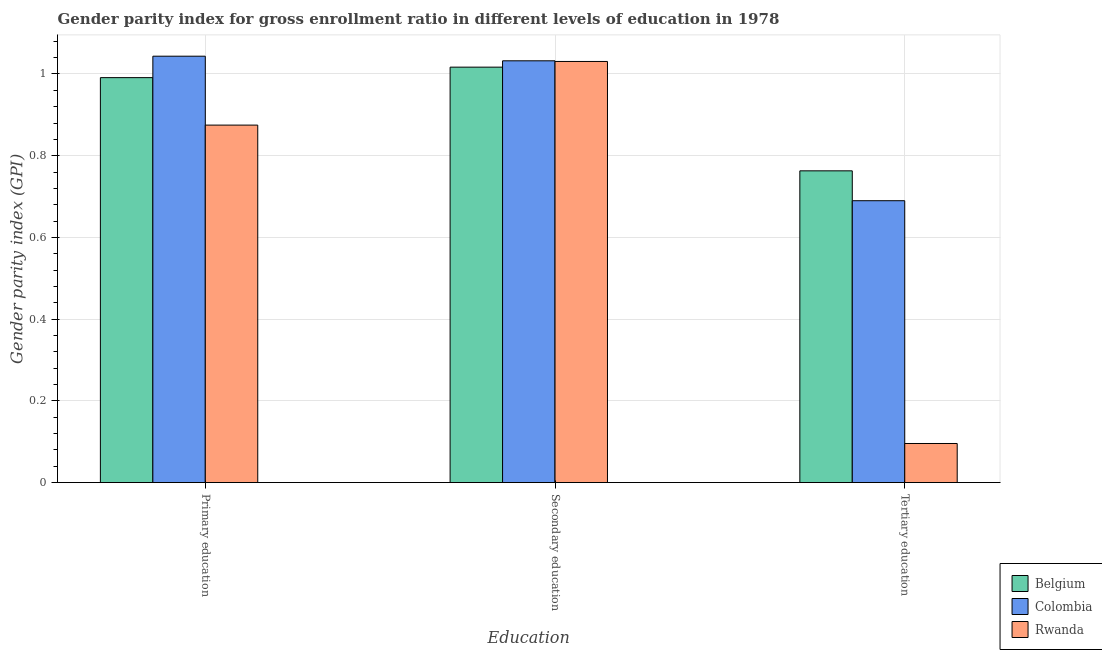How many different coloured bars are there?
Make the answer very short. 3. Are the number of bars per tick equal to the number of legend labels?
Your answer should be compact. Yes. What is the label of the 2nd group of bars from the left?
Ensure brevity in your answer.  Secondary education. What is the gender parity index in tertiary education in Belgium?
Keep it short and to the point. 0.76. Across all countries, what is the maximum gender parity index in tertiary education?
Keep it short and to the point. 0.76. Across all countries, what is the minimum gender parity index in primary education?
Ensure brevity in your answer.  0.87. In which country was the gender parity index in secondary education maximum?
Offer a terse response. Colombia. In which country was the gender parity index in primary education minimum?
Your answer should be very brief. Rwanda. What is the total gender parity index in tertiary education in the graph?
Your answer should be very brief. 1.55. What is the difference between the gender parity index in tertiary education in Belgium and that in Rwanda?
Your answer should be very brief. 0.67. What is the difference between the gender parity index in tertiary education in Belgium and the gender parity index in primary education in Rwanda?
Keep it short and to the point. -0.11. What is the average gender parity index in secondary education per country?
Offer a very short reply. 1.03. What is the difference between the gender parity index in secondary education and gender parity index in tertiary education in Rwanda?
Keep it short and to the point. 0.93. In how many countries, is the gender parity index in secondary education greater than 0.16 ?
Your answer should be compact. 3. What is the ratio of the gender parity index in primary education in Rwanda to that in Colombia?
Offer a terse response. 0.84. Is the difference between the gender parity index in secondary education in Belgium and Rwanda greater than the difference between the gender parity index in primary education in Belgium and Rwanda?
Your answer should be compact. No. What is the difference between the highest and the second highest gender parity index in tertiary education?
Ensure brevity in your answer.  0.07. What is the difference between the highest and the lowest gender parity index in secondary education?
Provide a short and direct response. 0.02. What does the 2nd bar from the left in Secondary education represents?
Your response must be concise. Colombia. Is it the case that in every country, the sum of the gender parity index in primary education and gender parity index in secondary education is greater than the gender parity index in tertiary education?
Keep it short and to the point. Yes. Where does the legend appear in the graph?
Keep it short and to the point. Bottom right. How are the legend labels stacked?
Keep it short and to the point. Vertical. What is the title of the graph?
Your response must be concise. Gender parity index for gross enrollment ratio in different levels of education in 1978. Does "Algeria" appear as one of the legend labels in the graph?
Your answer should be compact. No. What is the label or title of the X-axis?
Offer a terse response. Education. What is the label or title of the Y-axis?
Offer a terse response. Gender parity index (GPI). What is the Gender parity index (GPI) of Belgium in Primary education?
Ensure brevity in your answer.  0.99. What is the Gender parity index (GPI) in Colombia in Primary education?
Give a very brief answer. 1.04. What is the Gender parity index (GPI) in Rwanda in Primary education?
Offer a very short reply. 0.87. What is the Gender parity index (GPI) of Belgium in Secondary education?
Your answer should be compact. 1.02. What is the Gender parity index (GPI) in Colombia in Secondary education?
Your response must be concise. 1.03. What is the Gender parity index (GPI) of Rwanda in Secondary education?
Ensure brevity in your answer.  1.03. What is the Gender parity index (GPI) of Belgium in Tertiary education?
Offer a terse response. 0.76. What is the Gender parity index (GPI) of Colombia in Tertiary education?
Your answer should be very brief. 0.69. What is the Gender parity index (GPI) of Rwanda in Tertiary education?
Keep it short and to the point. 0.1. Across all Education, what is the maximum Gender parity index (GPI) of Belgium?
Offer a terse response. 1.02. Across all Education, what is the maximum Gender parity index (GPI) of Colombia?
Give a very brief answer. 1.04. Across all Education, what is the maximum Gender parity index (GPI) of Rwanda?
Make the answer very short. 1.03. Across all Education, what is the minimum Gender parity index (GPI) of Belgium?
Your response must be concise. 0.76. Across all Education, what is the minimum Gender parity index (GPI) in Colombia?
Provide a short and direct response. 0.69. Across all Education, what is the minimum Gender parity index (GPI) in Rwanda?
Offer a terse response. 0.1. What is the total Gender parity index (GPI) of Belgium in the graph?
Provide a succinct answer. 2.77. What is the total Gender parity index (GPI) in Colombia in the graph?
Give a very brief answer. 2.77. What is the total Gender parity index (GPI) of Rwanda in the graph?
Provide a short and direct response. 2. What is the difference between the Gender parity index (GPI) in Belgium in Primary education and that in Secondary education?
Ensure brevity in your answer.  -0.03. What is the difference between the Gender parity index (GPI) of Colombia in Primary education and that in Secondary education?
Keep it short and to the point. 0.01. What is the difference between the Gender parity index (GPI) in Rwanda in Primary education and that in Secondary education?
Your answer should be compact. -0.16. What is the difference between the Gender parity index (GPI) in Belgium in Primary education and that in Tertiary education?
Make the answer very short. 0.23. What is the difference between the Gender parity index (GPI) in Colombia in Primary education and that in Tertiary education?
Give a very brief answer. 0.35. What is the difference between the Gender parity index (GPI) in Rwanda in Primary education and that in Tertiary education?
Provide a succinct answer. 0.78. What is the difference between the Gender parity index (GPI) in Belgium in Secondary education and that in Tertiary education?
Make the answer very short. 0.25. What is the difference between the Gender parity index (GPI) of Colombia in Secondary education and that in Tertiary education?
Provide a short and direct response. 0.34. What is the difference between the Gender parity index (GPI) of Rwanda in Secondary education and that in Tertiary education?
Your answer should be very brief. 0.94. What is the difference between the Gender parity index (GPI) in Belgium in Primary education and the Gender parity index (GPI) in Colombia in Secondary education?
Provide a short and direct response. -0.04. What is the difference between the Gender parity index (GPI) in Belgium in Primary education and the Gender parity index (GPI) in Rwanda in Secondary education?
Your answer should be compact. -0.04. What is the difference between the Gender parity index (GPI) in Colombia in Primary education and the Gender parity index (GPI) in Rwanda in Secondary education?
Offer a terse response. 0.01. What is the difference between the Gender parity index (GPI) in Belgium in Primary education and the Gender parity index (GPI) in Colombia in Tertiary education?
Offer a terse response. 0.3. What is the difference between the Gender parity index (GPI) in Belgium in Primary education and the Gender parity index (GPI) in Rwanda in Tertiary education?
Make the answer very short. 0.9. What is the difference between the Gender parity index (GPI) of Colombia in Primary education and the Gender parity index (GPI) of Rwanda in Tertiary education?
Offer a very short reply. 0.95. What is the difference between the Gender parity index (GPI) of Belgium in Secondary education and the Gender parity index (GPI) of Colombia in Tertiary education?
Offer a very short reply. 0.33. What is the difference between the Gender parity index (GPI) of Belgium in Secondary education and the Gender parity index (GPI) of Rwanda in Tertiary education?
Your answer should be compact. 0.92. What is the difference between the Gender parity index (GPI) of Colombia in Secondary education and the Gender parity index (GPI) of Rwanda in Tertiary education?
Ensure brevity in your answer.  0.94. What is the average Gender parity index (GPI) of Belgium per Education?
Give a very brief answer. 0.92. What is the average Gender parity index (GPI) in Colombia per Education?
Keep it short and to the point. 0.92. What is the average Gender parity index (GPI) in Rwanda per Education?
Offer a terse response. 0.67. What is the difference between the Gender parity index (GPI) in Belgium and Gender parity index (GPI) in Colombia in Primary education?
Your answer should be compact. -0.05. What is the difference between the Gender parity index (GPI) of Belgium and Gender parity index (GPI) of Rwanda in Primary education?
Ensure brevity in your answer.  0.12. What is the difference between the Gender parity index (GPI) of Colombia and Gender parity index (GPI) of Rwanda in Primary education?
Offer a very short reply. 0.17. What is the difference between the Gender parity index (GPI) in Belgium and Gender parity index (GPI) in Colombia in Secondary education?
Make the answer very short. -0.02. What is the difference between the Gender parity index (GPI) in Belgium and Gender parity index (GPI) in Rwanda in Secondary education?
Offer a terse response. -0.01. What is the difference between the Gender parity index (GPI) of Colombia and Gender parity index (GPI) of Rwanda in Secondary education?
Provide a succinct answer. 0. What is the difference between the Gender parity index (GPI) in Belgium and Gender parity index (GPI) in Colombia in Tertiary education?
Offer a very short reply. 0.07. What is the difference between the Gender parity index (GPI) of Belgium and Gender parity index (GPI) of Rwanda in Tertiary education?
Give a very brief answer. 0.67. What is the difference between the Gender parity index (GPI) in Colombia and Gender parity index (GPI) in Rwanda in Tertiary education?
Your answer should be very brief. 0.59. What is the ratio of the Gender parity index (GPI) in Belgium in Primary education to that in Secondary education?
Provide a succinct answer. 0.97. What is the ratio of the Gender parity index (GPI) of Colombia in Primary education to that in Secondary education?
Provide a succinct answer. 1.01. What is the ratio of the Gender parity index (GPI) in Rwanda in Primary education to that in Secondary education?
Your answer should be very brief. 0.85. What is the ratio of the Gender parity index (GPI) in Belgium in Primary education to that in Tertiary education?
Provide a short and direct response. 1.3. What is the ratio of the Gender parity index (GPI) in Colombia in Primary education to that in Tertiary education?
Ensure brevity in your answer.  1.51. What is the ratio of the Gender parity index (GPI) in Rwanda in Primary education to that in Tertiary education?
Your response must be concise. 9.14. What is the ratio of the Gender parity index (GPI) in Belgium in Secondary education to that in Tertiary education?
Make the answer very short. 1.33. What is the ratio of the Gender parity index (GPI) in Colombia in Secondary education to that in Tertiary education?
Your answer should be compact. 1.5. What is the ratio of the Gender parity index (GPI) of Rwanda in Secondary education to that in Tertiary education?
Give a very brief answer. 10.77. What is the difference between the highest and the second highest Gender parity index (GPI) in Belgium?
Give a very brief answer. 0.03. What is the difference between the highest and the second highest Gender parity index (GPI) of Colombia?
Provide a succinct answer. 0.01. What is the difference between the highest and the second highest Gender parity index (GPI) in Rwanda?
Offer a very short reply. 0.16. What is the difference between the highest and the lowest Gender parity index (GPI) of Belgium?
Give a very brief answer. 0.25. What is the difference between the highest and the lowest Gender parity index (GPI) in Colombia?
Provide a succinct answer. 0.35. What is the difference between the highest and the lowest Gender parity index (GPI) in Rwanda?
Give a very brief answer. 0.94. 